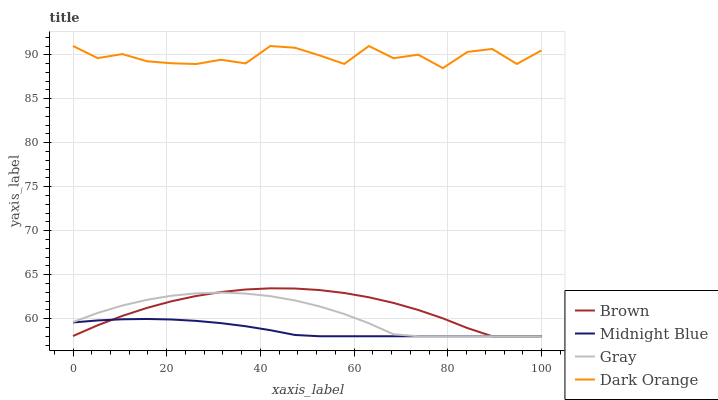Does Brown have the minimum area under the curve?
Answer yes or no. No. Does Brown have the maximum area under the curve?
Answer yes or no. No. Is Brown the smoothest?
Answer yes or no. No. Is Brown the roughest?
Answer yes or no. No. Does Brown have the highest value?
Answer yes or no. No. Is Brown less than Dark Orange?
Answer yes or no. Yes. Is Dark Orange greater than Brown?
Answer yes or no. Yes. Does Brown intersect Dark Orange?
Answer yes or no. No. 